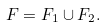Convert formula to latex. <formula><loc_0><loc_0><loc_500><loc_500>F = F _ { 1 } \cup F _ { 2 } .</formula> 